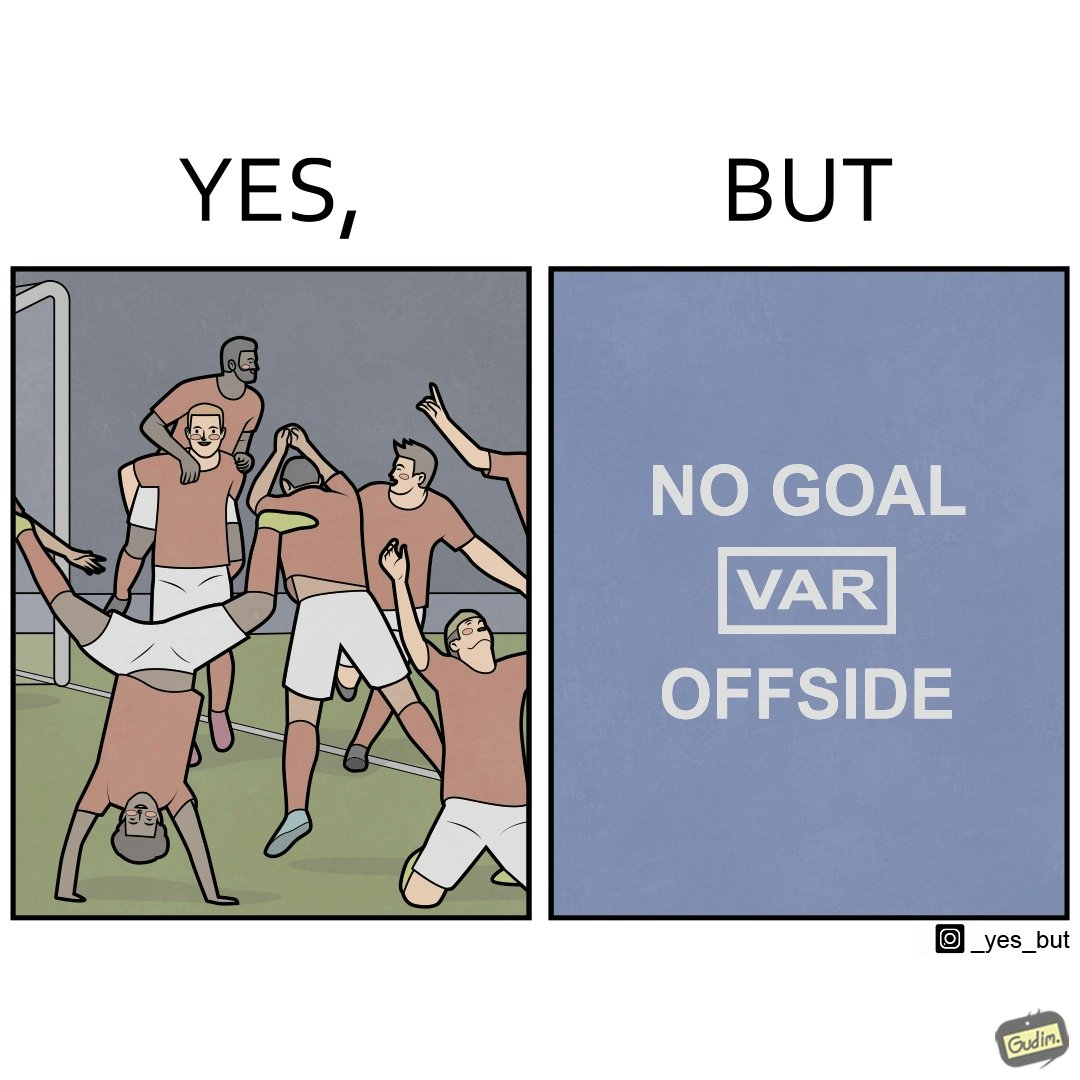Is this image satirical or non-satirical? Yes, this image is satirical. 